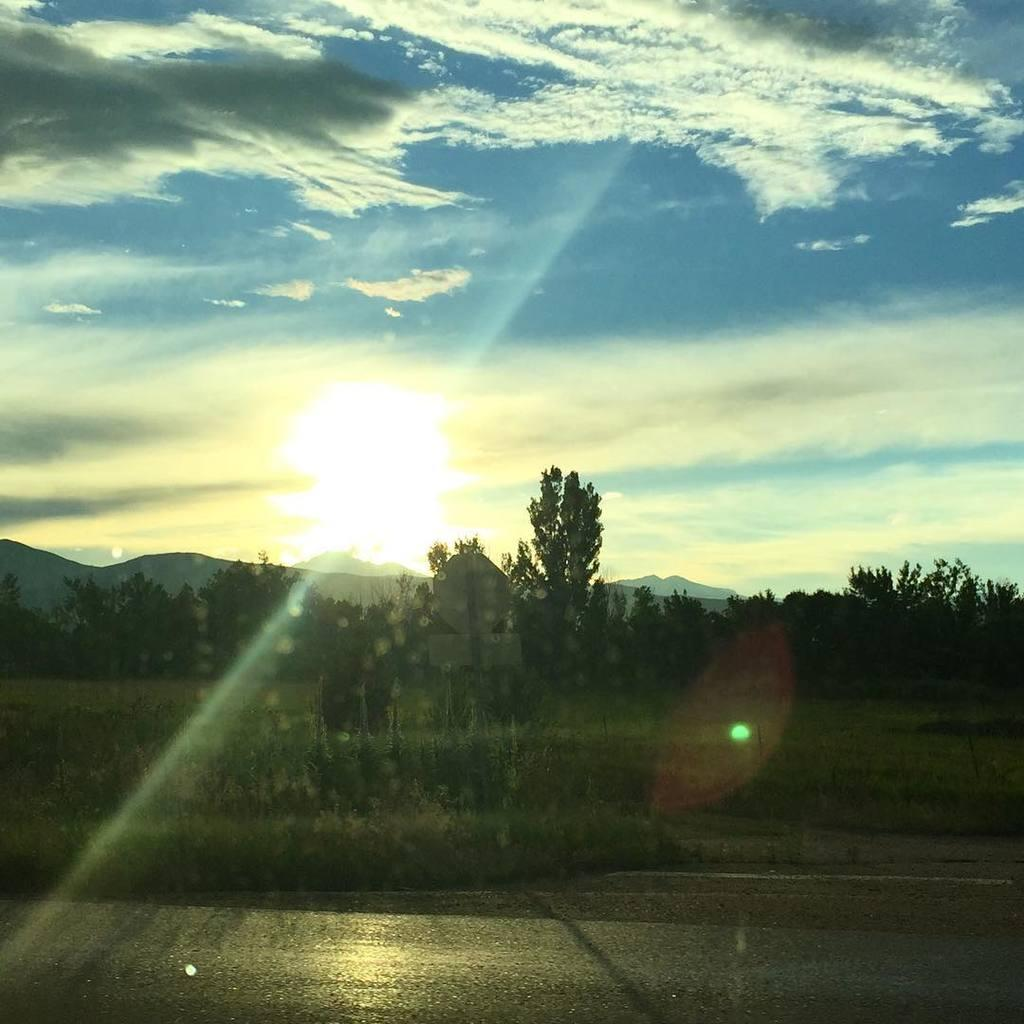What is located at the bottom of the image? There is a road at the bottom of the image. What can be seen in the center of the image? There are trees and grass in the center of the image. What is visible in the background of the image? There are mountains and sky visible in the background of the image. Can the sun be seen in the image? Yes, the sun is observable in the sky. What type of carriage can be seen in the image? There is no carriage present in the image. Can you describe the romantic interaction between the trees and grass in the image? The image does not depict any romantic interactions between the trees and grass; it is a landscape scene with trees, grass, mountains, and sky. 